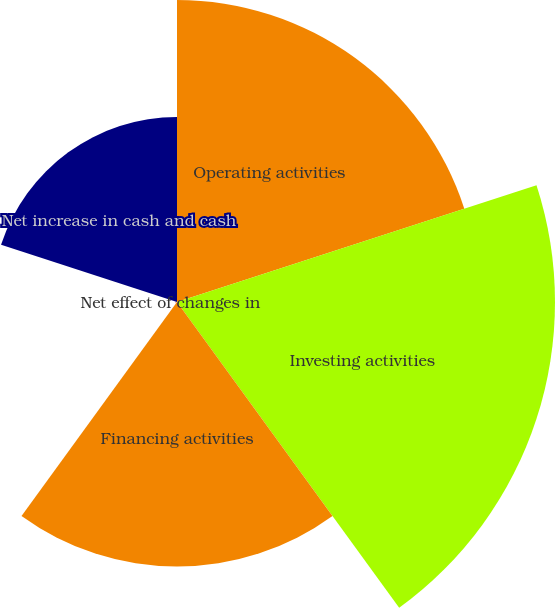<chart> <loc_0><loc_0><loc_500><loc_500><pie_chart><fcel>Operating activities<fcel>Investing activities<fcel>Financing activities<fcel>Net effect of changes in<fcel>Net increase in cash and cash<nl><fcel>26.7%<fcel>33.41%<fcel>23.38%<fcel>0.16%<fcel>16.35%<nl></chart> 